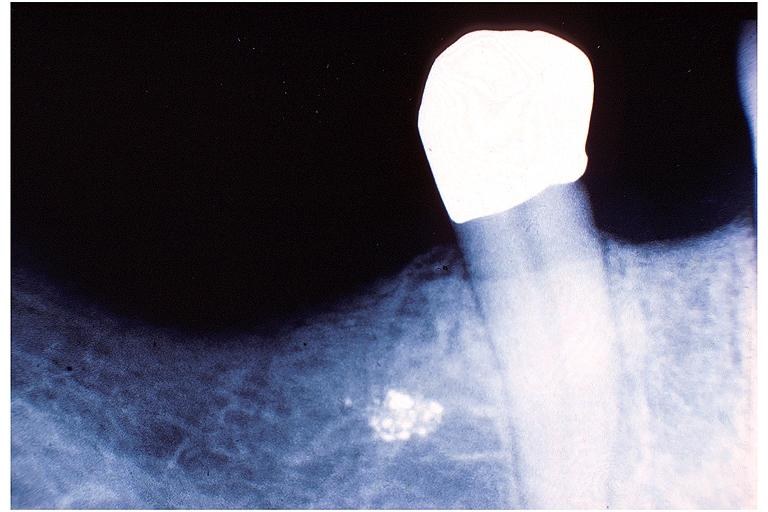where is this?
Answer the question using a single word or phrase. Oral 